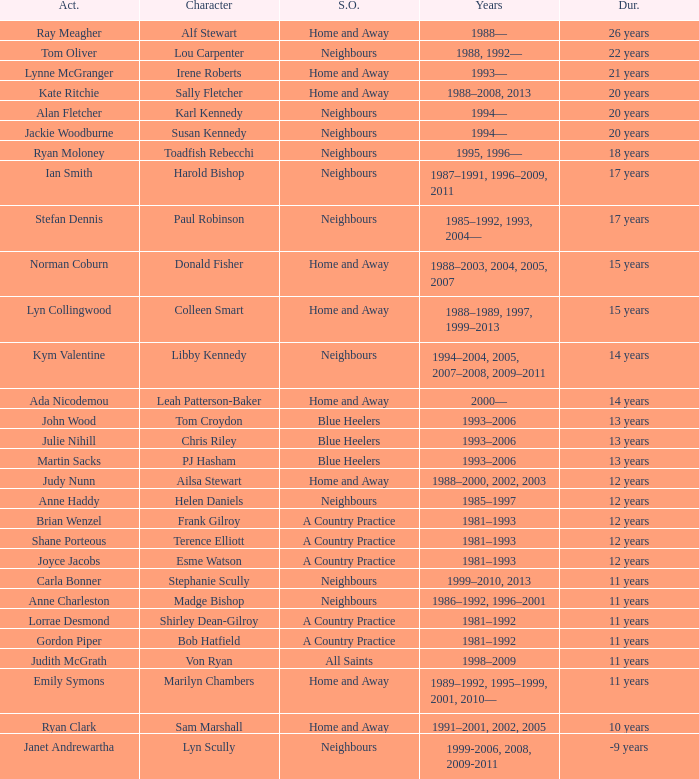How long did Joyce Jacobs portray her character on her show? 12 years. 